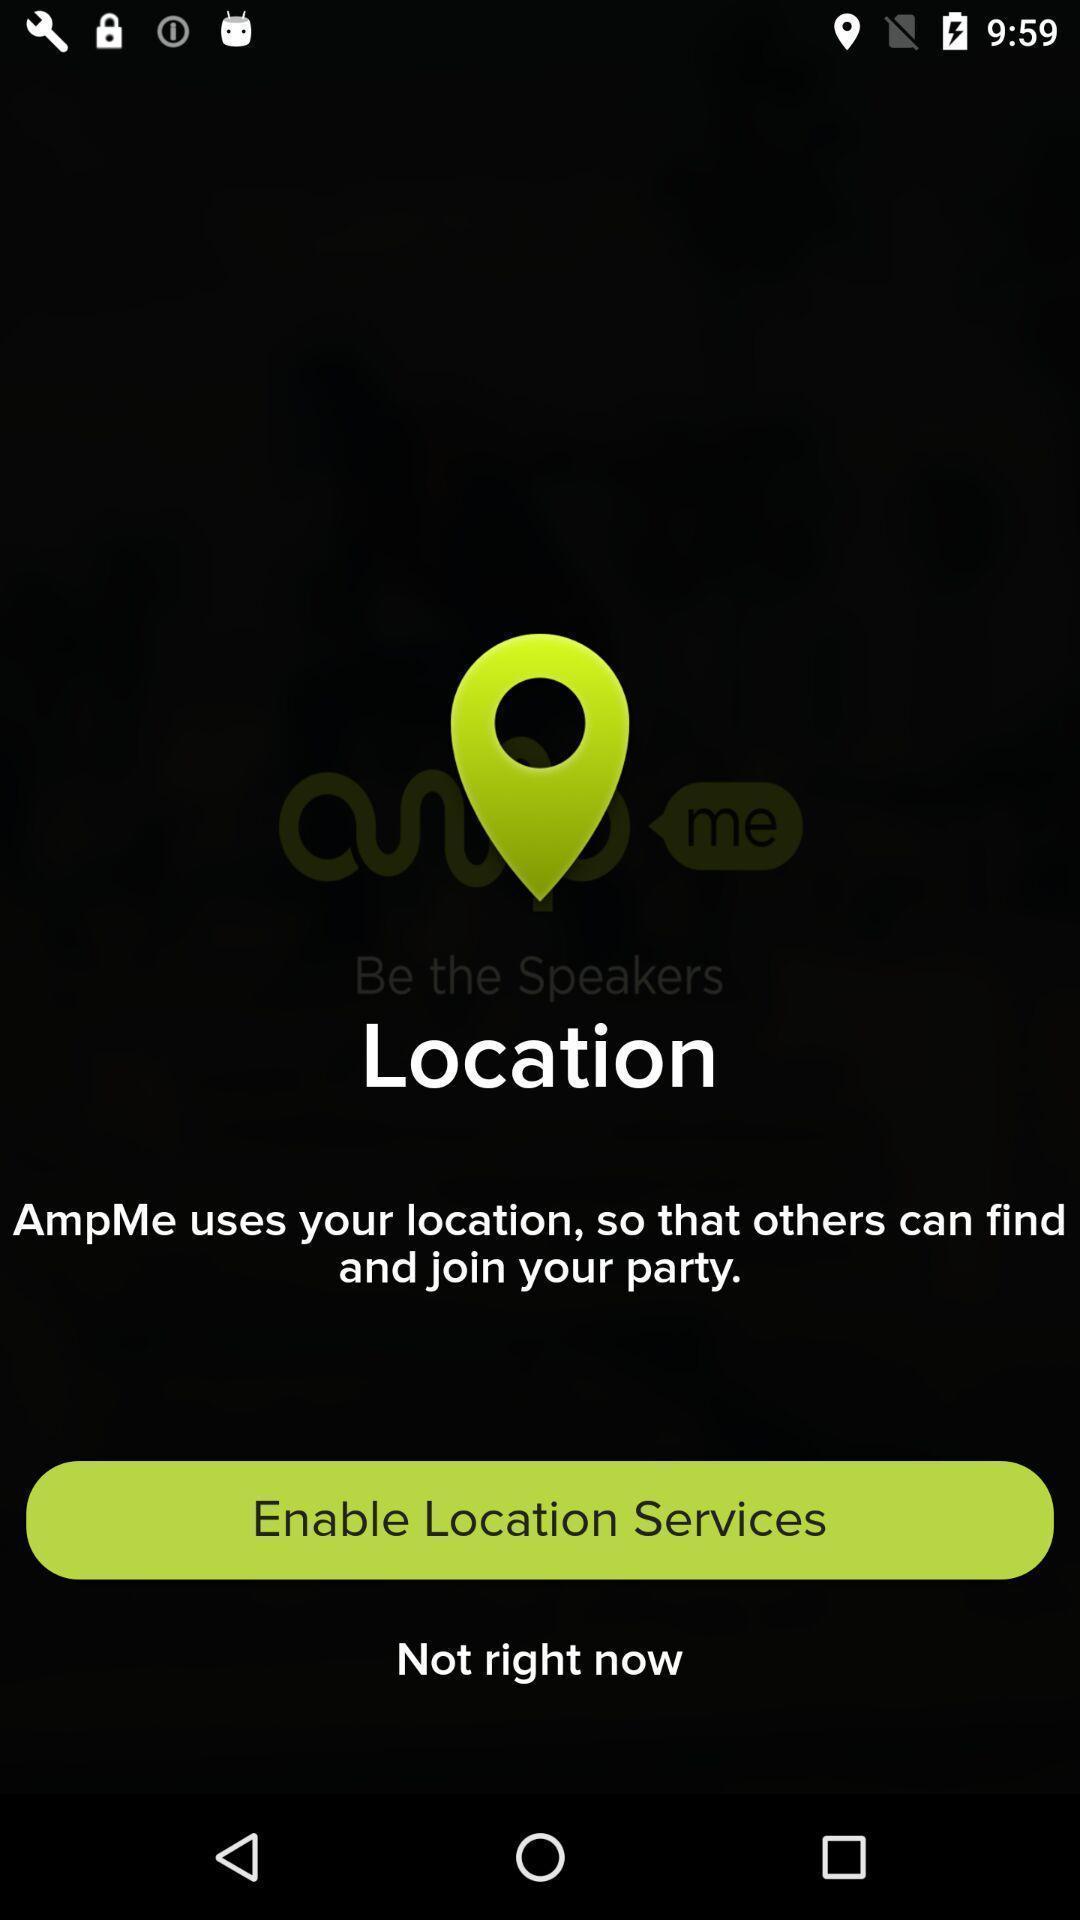Describe the visual elements of this screenshot. Screen displaying the page to enable location services. 